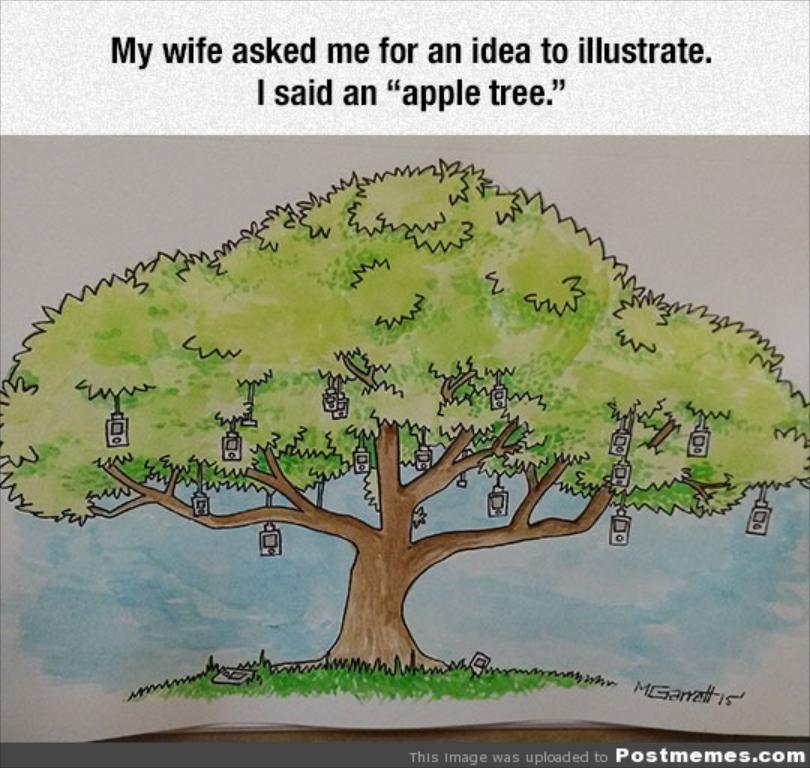In one or two sentences, can you explain what this image depicts? This is a poster. In this picture we can see some text on top and at the bottom of the picture. There are a few objects visible on a tree. We can see some objects on the grass. 